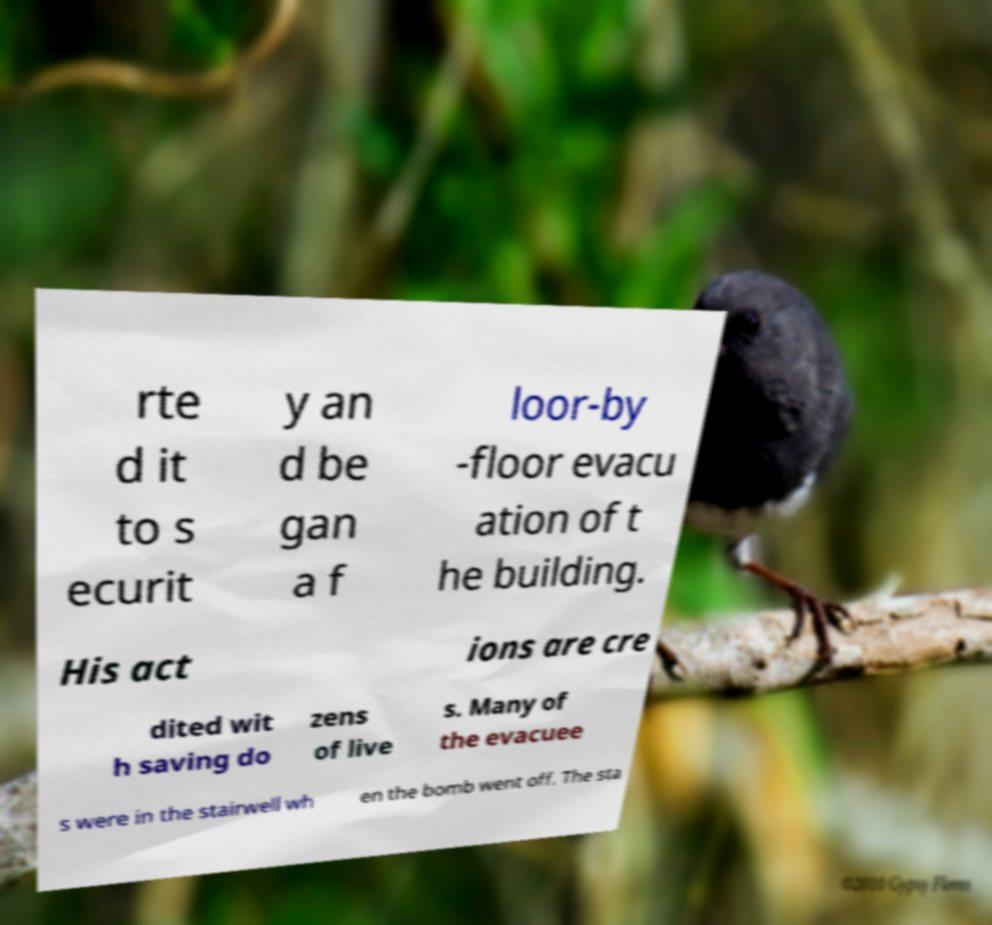Please identify and transcribe the text found in this image. rte d it to s ecurit y an d be gan a f loor-by -floor evacu ation of t he building. His act ions are cre dited wit h saving do zens of live s. Many of the evacuee s were in the stairwell wh en the bomb went off. The sta 